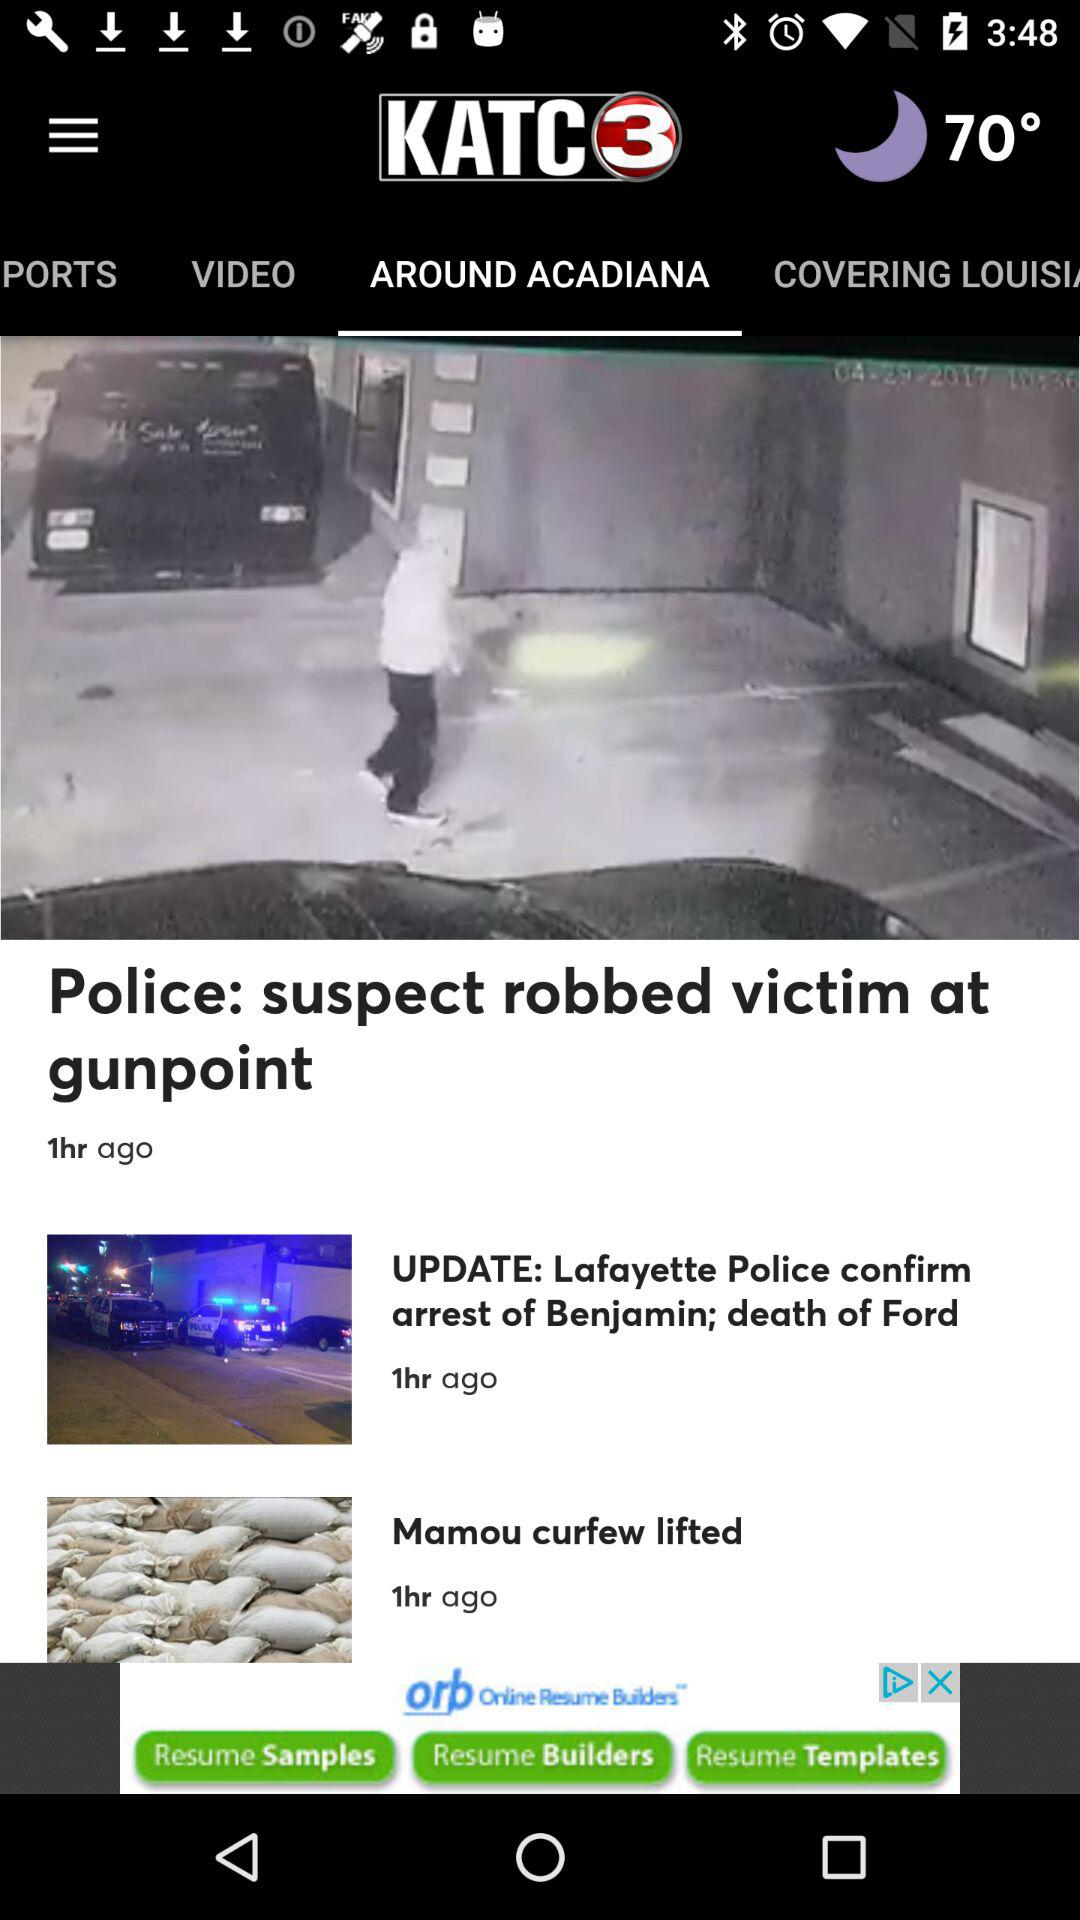How many hours ago was the news "Mamou curfew lifted" posted? The news "Mamou curfew lifted" was posted 1 hour ago. 